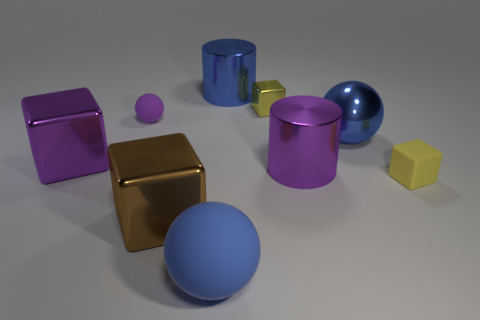There is another tiny block that is the same color as the matte cube; what material is it?
Offer a terse response. Metal. Does the metallic ball have the same color as the big rubber object?
Your response must be concise. Yes. Do the tiny yellow cube in front of the purple rubber ball and the large ball left of the small yellow metal cube have the same material?
Make the answer very short. Yes. Do the shiny ball behind the large brown metal object and the big matte object have the same color?
Give a very brief answer. Yes. How many brown metallic objects are on the right side of the large brown metal thing?
Offer a terse response. 0. Is the material of the purple cylinder the same as the blue thing that is behind the purple rubber ball?
Make the answer very short. Yes. What is the size of the blue cylinder that is made of the same material as the brown block?
Provide a short and direct response. Large. Is the number of big blue spheres on the right side of the large brown cube greater than the number of blue rubber objects that are left of the purple cube?
Your response must be concise. Yes. Is there a small cyan matte thing of the same shape as the blue rubber thing?
Ensure brevity in your answer.  No. There is a yellow matte block that is in front of the purple rubber ball; does it have the same size as the small yellow metallic block?
Provide a succinct answer. Yes. 